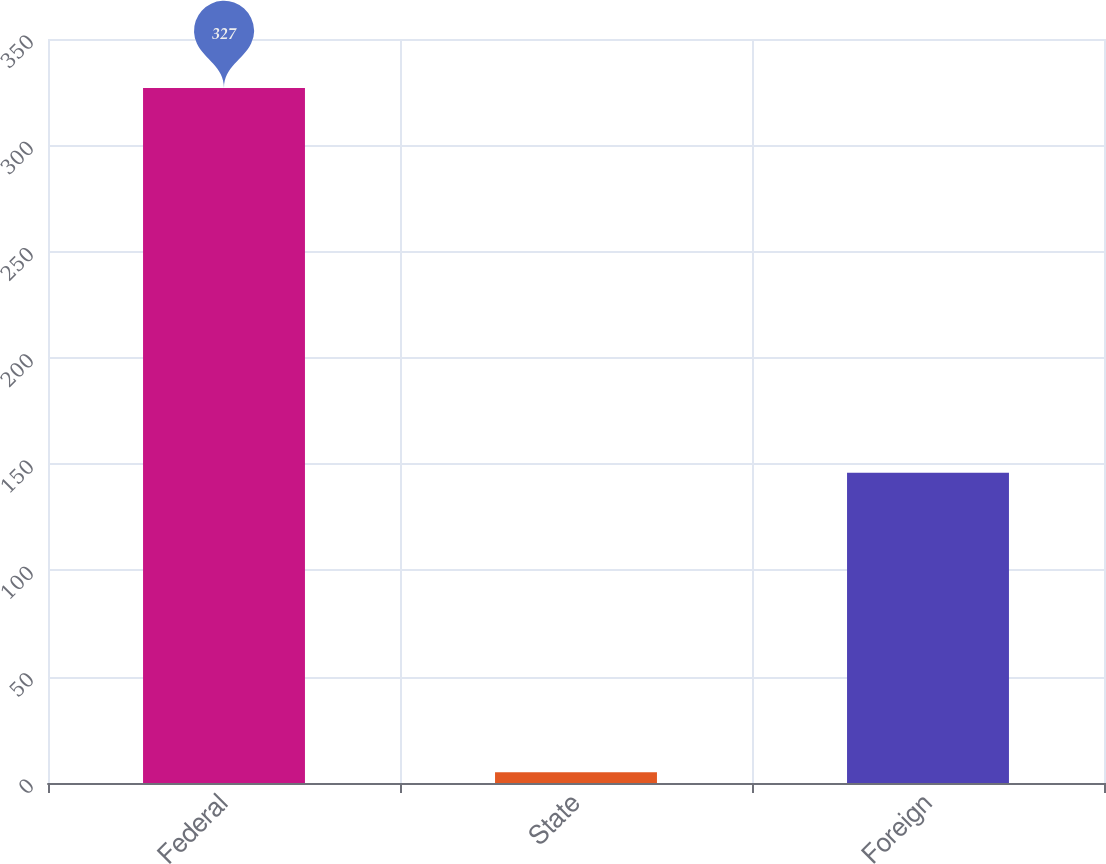<chart> <loc_0><loc_0><loc_500><loc_500><bar_chart><fcel>Federal<fcel>State<fcel>Foreign<nl><fcel>327<fcel>5<fcel>146<nl></chart> 